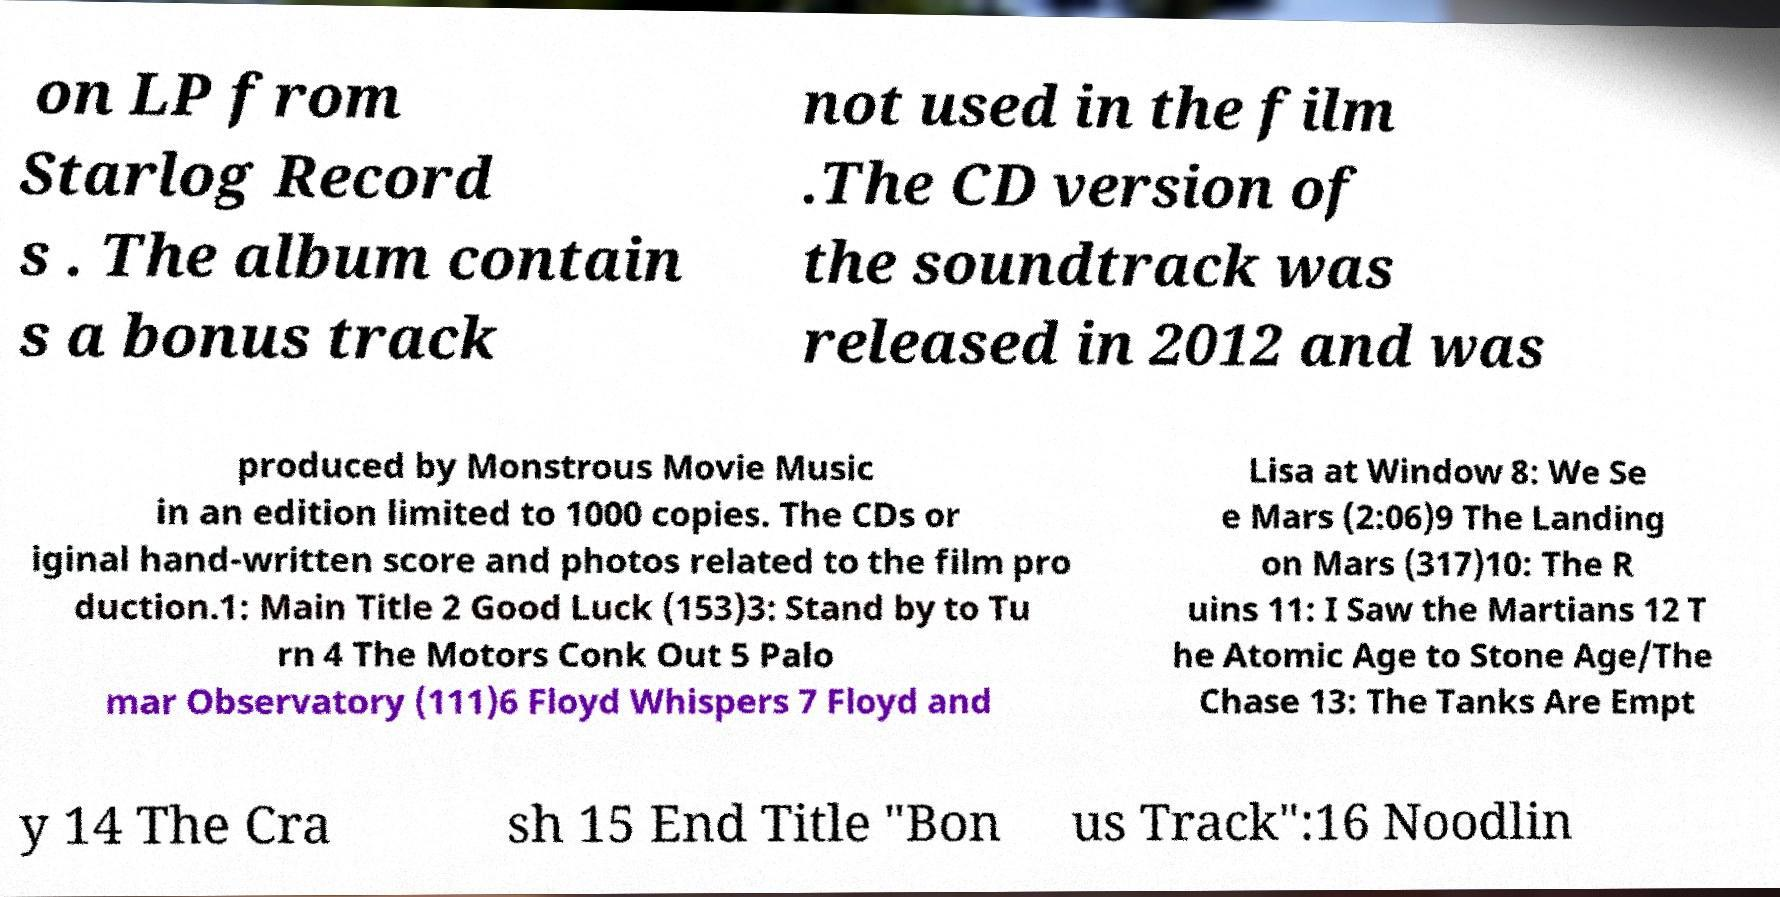Can you read and provide the text displayed in the image?This photo seems to have some interesting text. Can you extract and type it out for me? on LP from Starlog Record s . The album contain s a bonus track not used in the film .The CD version of the soundtrack was released in 2012 and was produced by Monstrous Movie Music in an edition limited to 1000 copies. The CDs or iginal hand-written score and photos related to the film pro duction.1: Main Title 2 Good Luck (153)3: Stand by to Tu rn 4 The Motors Conk Out 5 Palo mar Observatory (111)6 Floyd Whispers 7 Floyd and Lisa at Window 8: We Se e Mars (2:06)9 The Landing on Mars (317)10: The R uins 11: I Saw the Martians 12 T he Atomic Age to Stone Age/The Chase 13: The Tanks Are Empt y 14 The Cra sh 15 End Title "Bon us Track":16 Noodlin 